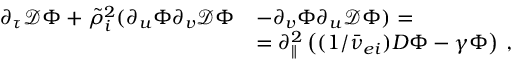<formula> <loc_0><loc_0><loc_500><loc_500>\begin{array} { r l } { \partial _ { \tau } \mathcal { D } \Phi + \tilde { \rho } _ { i } ^ { 2 } ( \partial _ { u } \Phi \partial _ { v } \mathcal { D } \Phi } & { - \partial _ { v } \Phi \partial _ { u } \mathcal { D } \Phi ) = } \\ & { = \partial _ { \| } ^ { 2 } \left ( ( 1 / \bar { \nu } _ { e i } ) D \Phi - \gamma \Phi \right ) \, , } \end{array}</formula> 